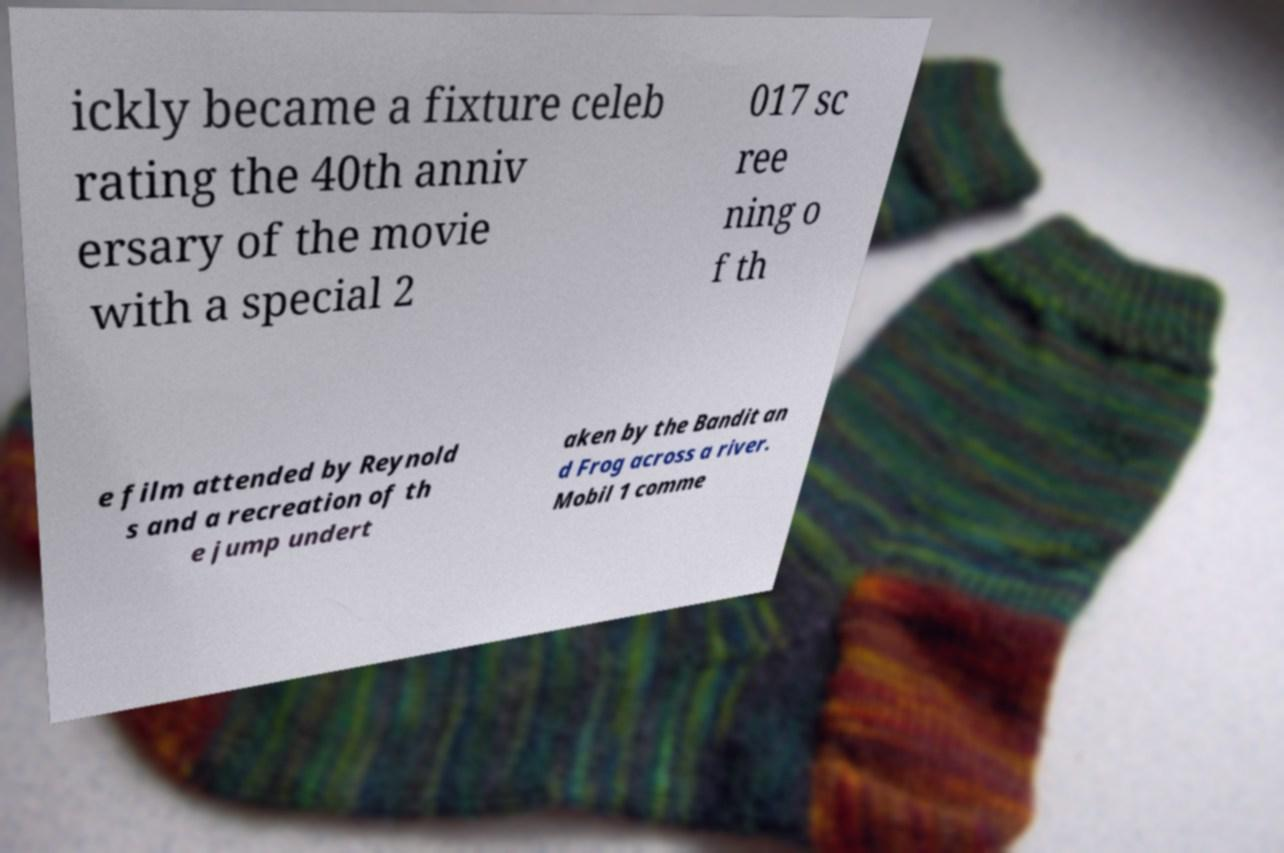What messages or text are displayed in this image? I need them in a readable, typed format. ickly became a fixture celeb rating the 40th anniv ersary of the movie with a special 2 017 sc ree ning o f th e film attended by Reynold s and a recreation of th e jump undert aken by the Bandit an d Frog across a river. Mobil 1 comme 